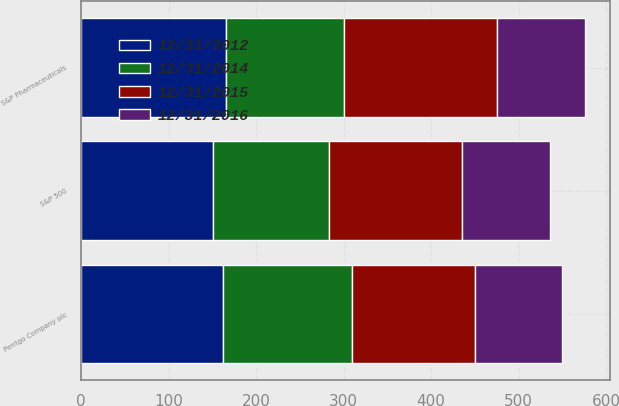Convert chart to OTSL. <chart><loc_0><loc_0><loc_500><loc_500><stacked_bar_chart><ecel><fcel>Perrigo Company plc<fcel>S&P 500<fcel>S&P Pharmaceuticals<nl><fcel>12/31/2016<fcel>100<fcel>100<fcel>100<nl><fcel>12/31/2014<fcel>147.94<fcel>132.39<fcel>135.23<nl><fcel>12/31/2012<fcel>161.6<fcel>150.51<fcel>165.27<nl><fcel>12/31/2015<fcel>140.3<fcel>152.59<fcel>174.84<nl></chart> 